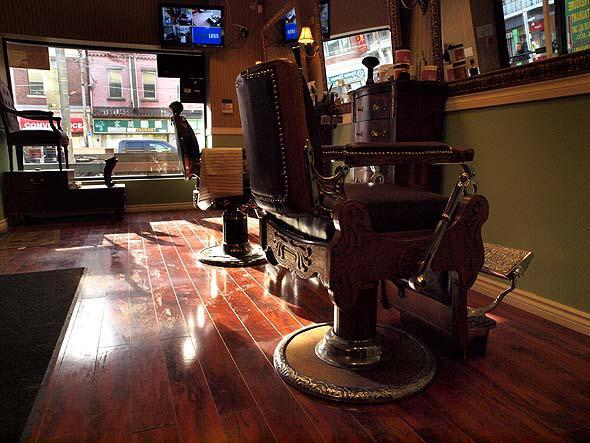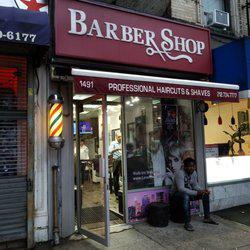The first image is the image on the left, the second image is the image on the right. For the images displayed, is the sentence "One image has exactly two barber chairs." factually correct? Answer yes or no. Yes. The first image is the image on the left, the second image is the image on the right. Assess this claim about the two images: "At least one of the images prominently features the storefront of a Barber Shop.". Correct or not? Answer yes or no. Yes. 